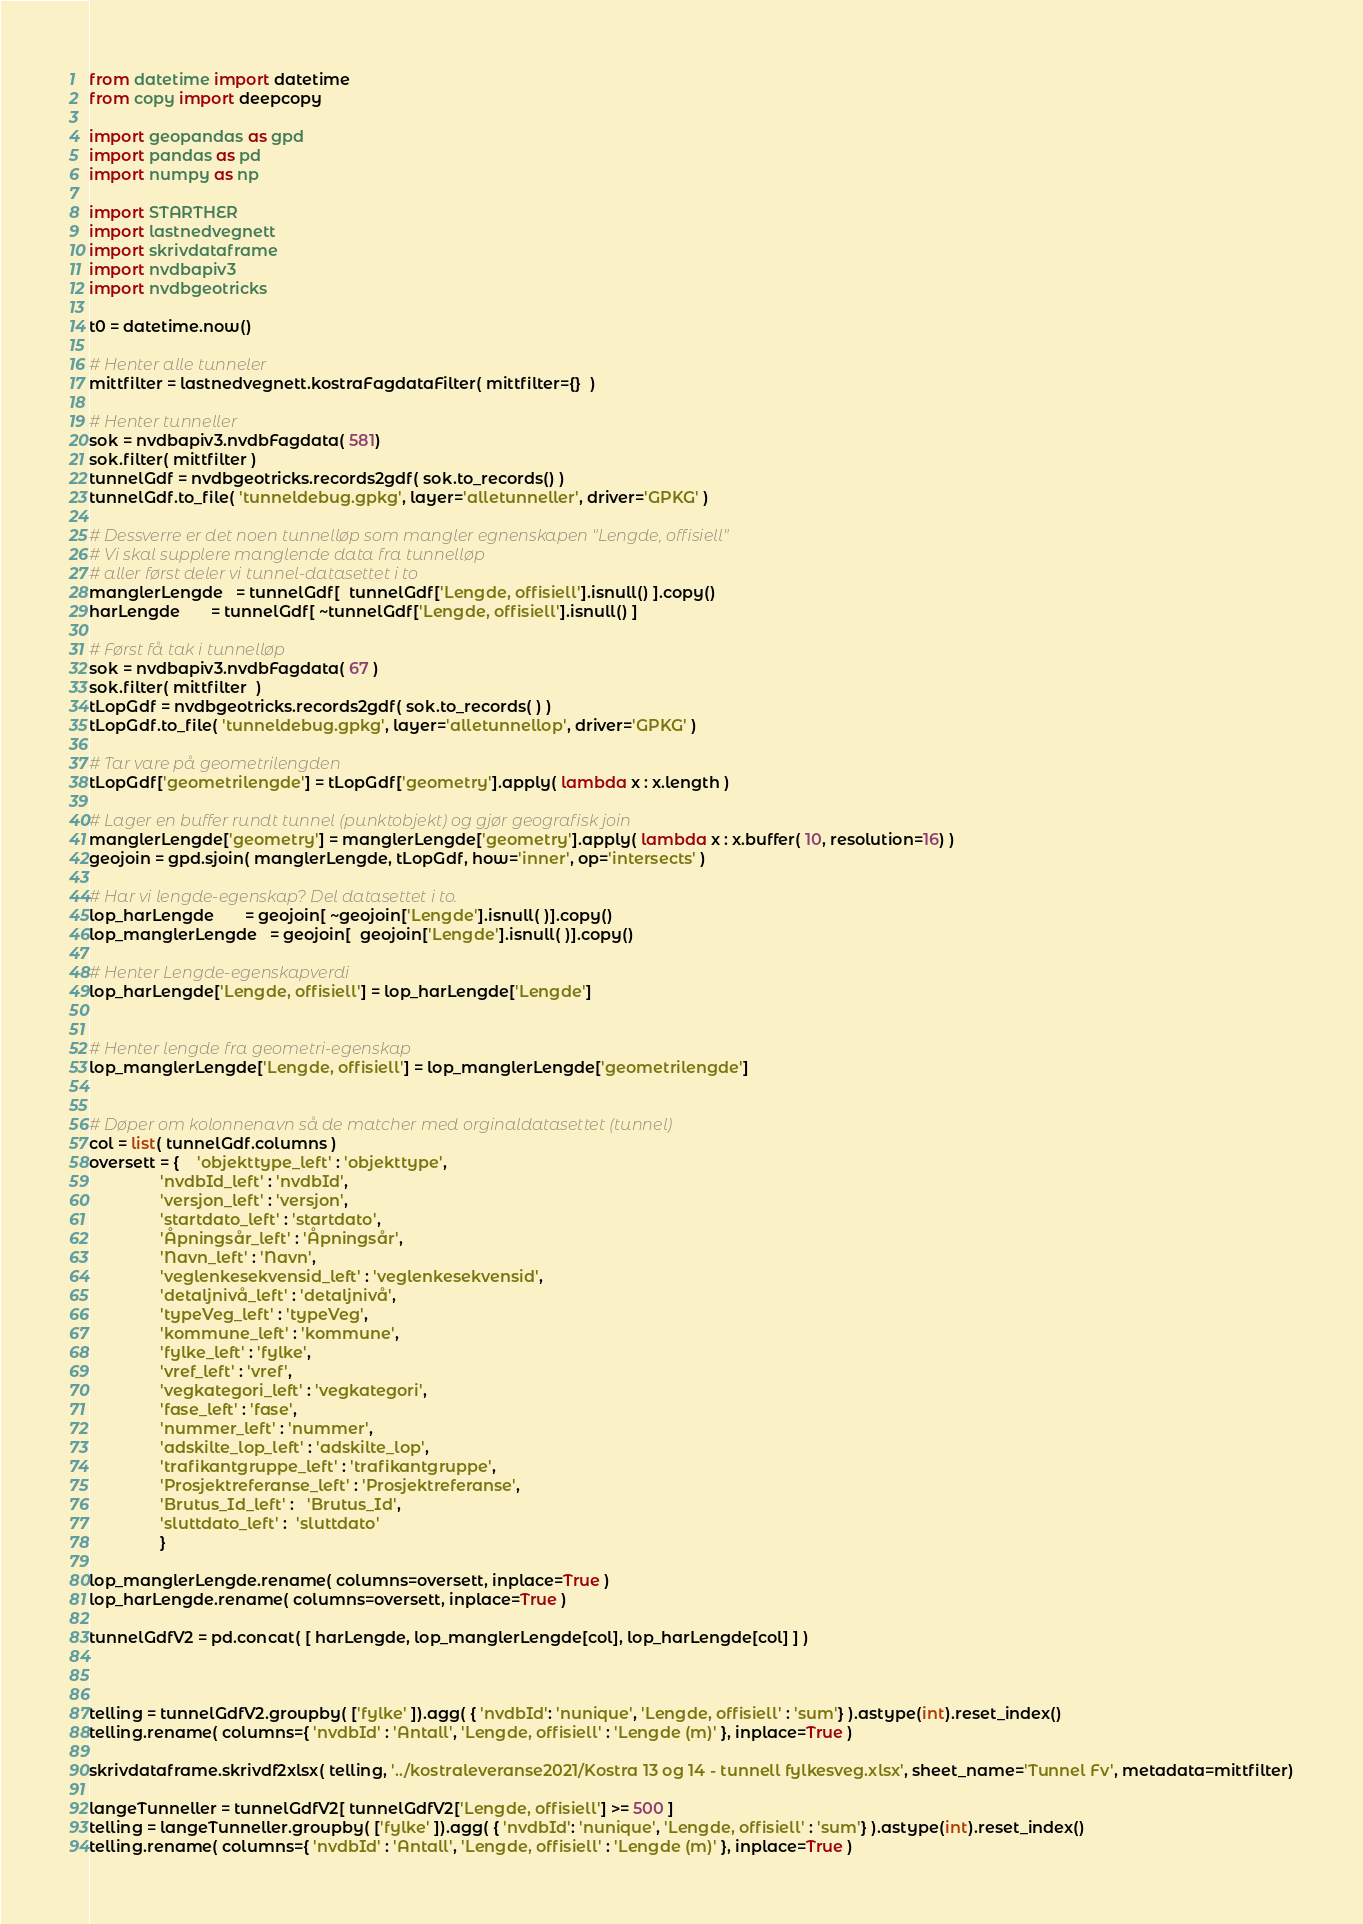Convert code to text. <code><loc_0><loc_0><loc_500><loc_500><_Python_>from datetime import datetime 
from copy import deepcopy 

import geopandas as gpd 
import pandas as pd
import numpy as np

import STARTHER
import lastnedvegnett  
import skrivdataframe
import nvdbapiv3
import nvdbgeotricks

t0 = datetime.now()

# Henter alle tunneler 
mittfilter = lastnedvegnett.kostraFagdataFilter( mittfilter={}  )

# Henter tunneller 
sok = nvdbapiv3.nvdbFagdata( 581)
sok.filter( mittfilter )
tunnelGdf = nvdbgeotricks.records2gdf( sok.to_records() )
tunnelGdf.to_file( 'tunneldebug.gpkg', layer='alletunneller', driver='GPKG' )

# Dessverre er det noen tunnelløp som mangler egnenskapen "Lengde, offisiell"
# Vi skal supplere manglende data fra tunnelløp 
# aller først deler vi tunnel-datasettet i to
manglerLengde   = tunnelGdf[  tunnelGdf['Lengde, offisiell'].isnull() ].copy()
harLengde       = tunnelGdf[ ~tunnelGdf['Lengde, offisiell'].isnull() ]

# Først få tak i tunnelløp 
sok = nvdbapiv3.nvdbFagdata( 67 )
sok.filter( mittfilter  ) 
tLopGdf = nvdbgeotricks.records2gdf( sok.to_records( ) )
tLopGdf.to_file( 'tunneldebug.gpkg', layer='alletunnellop', driver='GPKG' )

# Tar vare på geometrilengden 
tLopGdf['geometrilengde'] = tLopGdf['geometry'].apply( lambda x : x.length )

# Lager en buffer rundt tunnel (punktobjekt) og gjør geografisk join 
manglerLengde['geometry'] = manglerLengde['geometry'].apply( lambda x : x.buffer( 10, resolution=16) )
geojoin = gpd.sjoin( manglerLengde, tLopGdf, how='inner', op='intersects' )

# Har vi lengde-egenskap? Del datasettet i to. 
lop_harLengde       = geojoin[ ~geojoin['Lengde'].isnull( )].copy()
lop_manglerLengde   = geojoin[  geojoin['Lengde'].isnull( )].copy()

# Henter Lengde-egenskapverdi 
lop_harLengde['Lengde, offisiell'] = lop_harLengde['Lengde']


# Henter lengde fra geometri-egenskap
lop_manglerLengde['Lengde, offisiell'] = lop_manglerLengde['geometrilengde']


# Døper om kolonnenavn så de matcher med orginaldatasettet (tunnel)
col = list( tunnelGdf.columns )
oversett = {    'objekttype_left' : 'objekttype',
                'nvdbId_left' : 'nvdbId',
                'versjon_left' : 'versjon',
                'startdato_left' : 'startdato',
                'Åpningsår_left' : 'Åpningsår',
                'Navn_left' : 'Navn',
                'veglenkesekvensid_left' : 'veglenkesekvensid',
                'detaljnivå_left' : 'detaljnivå',
                'typeVeg_left' : 'typeVeg',
                'kommune_left' : 'kommune',
                'fylke_left' : 'fylke',
                'vref_left' : 'vref',
                'vegkategori_left' : 'vegkategori',
                'fase_left' : 'fase',
                'nummer_left' : 'nummer',
                'adskilte_lop_left' : 'adskilte_lop',
                'trafikantgruppe_left' : 'trafikantgruppe', 
                'Prosjektreferanse_left' : 'Prosjektreferanse', 
                'Brutus_Id_left' :   'Brutus_Id',
                'sluttdato_left' :  'sluttdato'
                }

lop_manglerLengde.rename( columns=oversett, inplace=True )
lop_harLengde.rename( columns=oversett, inplace=True )

tunnelGdfV2 = pd.concat( [ harLengde, lop_manglerLengde[col], lop_harLengde[col] ] )



telling = tunnelGdfV2.groupby( ['fylke' ]).agg( { 'nvdbId': 'nunique', 'Lengde, offisiell' : 'sum'} ).astype(int).reset_index()
telling.rename( columns={ 'nvdbId' : 'Antall', 'Lengde, offisiell' : 'Lengde (m)' }, inplace=True )

skrivdataframe.skrivdf2xlsx( telling, '../kostraleveranse2021/Kostra 13 og 14 - tunnell fylkesveg.xlsx', sheet_name='Tunnel Fv', metadata=mittfilter)

langeTunneller = tunnelGdfV2[ tunnelGdfV2['Lengde, offisiell'] >= 500 ]
telling = langeTunneller.groupby( ['fylke' ]).agg( { 'nvdbId': 'nunique', 'Lengde, offisiell' : 'sum'} ).astype(int).reset_index()
telling.rename( columns={ 'nvdbId' : 'Antall', 'Lengde, offisiell' : 'Lengde (m)' }, inplace=True )
</code> 